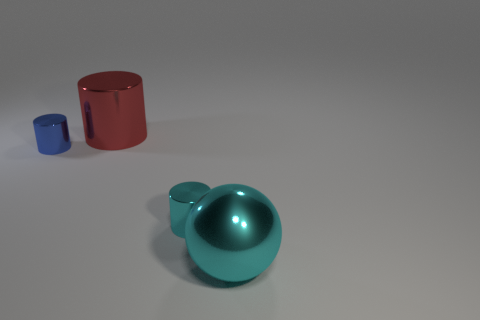Are these objects usually found together? The objects in the image—a teal sphere, a red cylinder, and a blue cylinder—are not typically found together in a specific context as they appear to be unrelated items. 